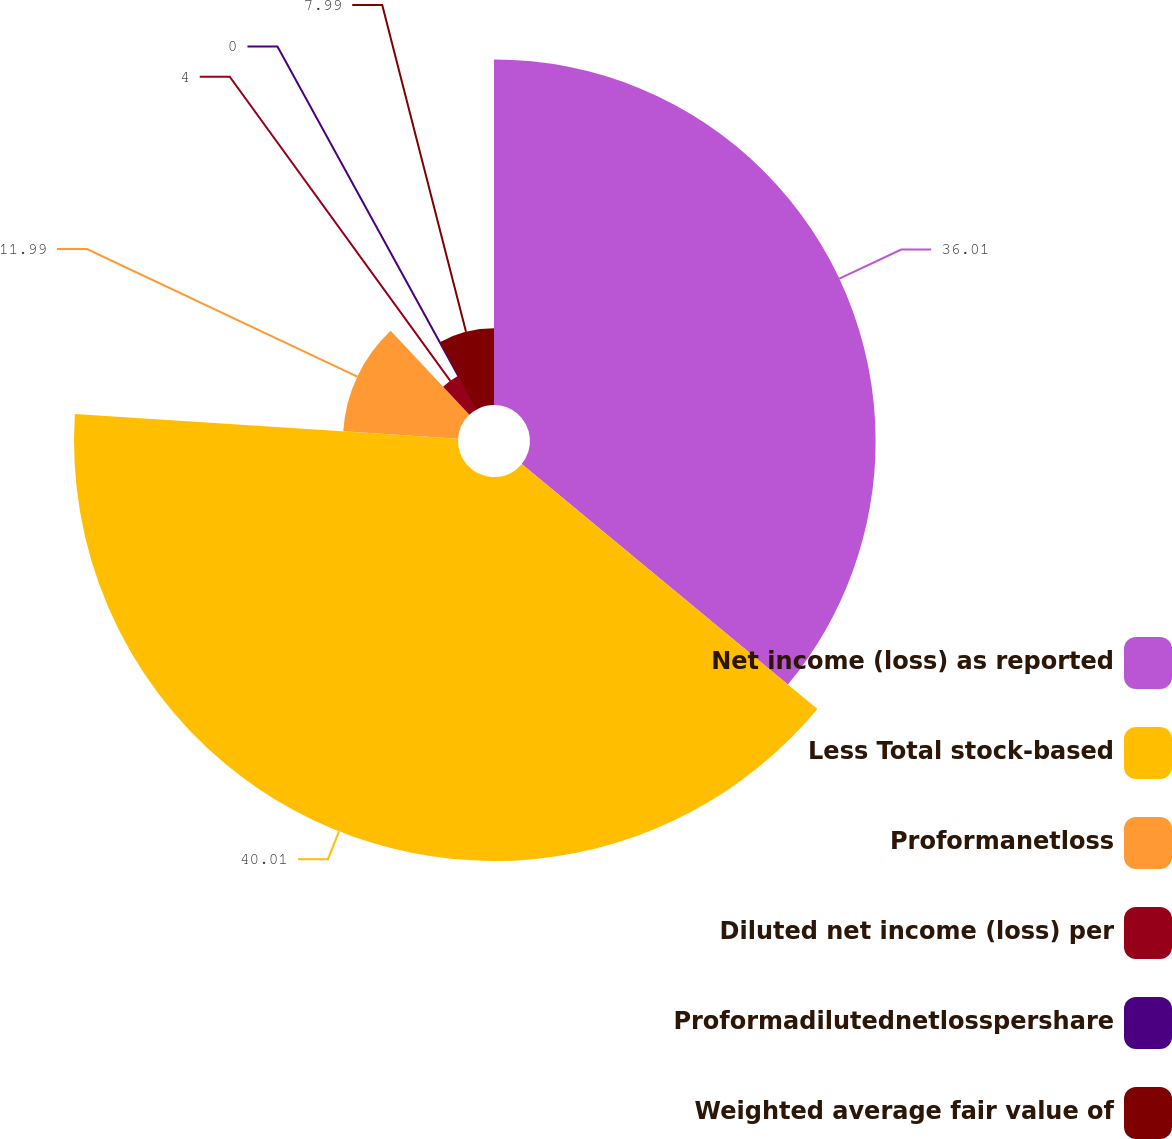Convert chart to OTSL. <chart><loc_0><loc_0><loc_500><loc_500><pie_chart><fcel>Net income (loss) as reported<fcel>Less Total stock-based<fcel>Proformanetloss<fcel>Diluted net income (loss) per<fcel>Proformadilutednetlosspershare<fcel>Weighted average fair value of<nl><fcel>36.01%<fcel>40.01%<fcel>11.99%<fcel>4.0%<fcel>0.0%<fcel>7.99%<nl></chart> 